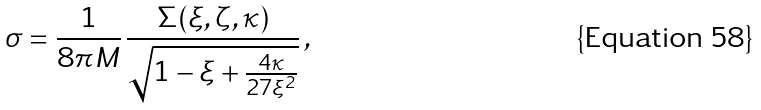<formula> <loc_0><loc_0><loc_500><loc_500>\sigma = \frac { 1 } { 8 \pi M } \, \frac { \Sigma ( \xi , \zeta , \kappa ) } { \sqrt { 1 - \xi + \frac { 4 \kappa } { 2 7 \xi ^ { 2 } } } } \, ,</formula> 